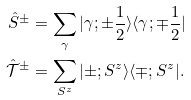Convert formula to latex. <formula><loc_0><loc_0><loc_500><loc_500>\hat { S } ^ { \pm } & = \sum _ { \gamma } | \gamma ; \pm \frac { 1 } { 2 } \rangle \langle \gamma ; \mp \frac { 1 } { 2 } | \\ \hat { \mathcal { T } } ^ { \pm } & = \sum _ { S ^ { z } } | \pm ; S ^ { z } \rangle \langle \mp ; S ^ { z } | .</formula> 